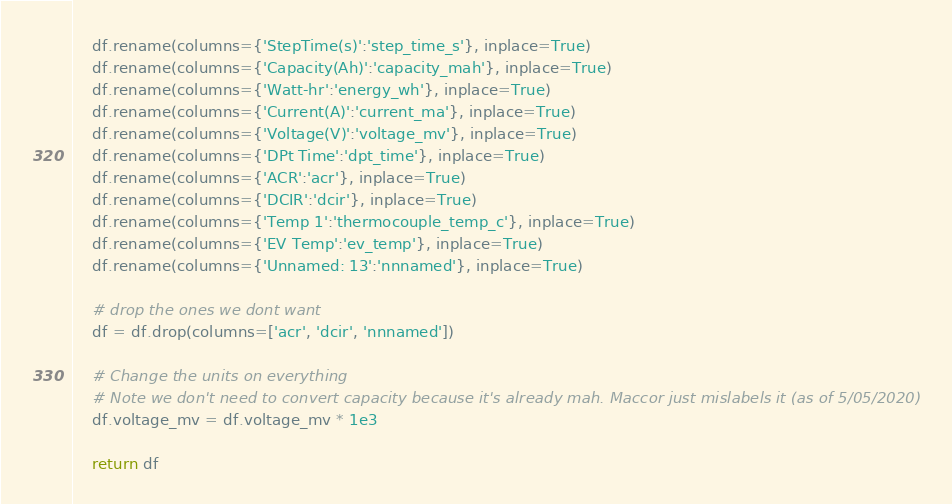<code> <loc_0><loc_0><loc_500><loc_500><_Python_>	df.rename(columns={'StepTime(s)':'step_time_s'}, inplace=True)
	df.rename(columns={'Capacity(Ah)':'capacity_mah'}, inplace=True)
	df.rename(columns={'Watt-hr':'energy_wh'}, inplace=True)
	df.rename(columns={'Current(A)':'current_ma'}, inplace=True)
	df.rename(columns={'Voltage(V)':'voltage_mv'}, inplace=True)
	df.rename(columns={'DPt Time':'dpt_time'}, inplace=True)
	df.rename(columns={'ACR':'acr'}, inplace=True)
	df.rename(columns={'DCIR':'dcir'}, inplace=True)
	df.rename(columns={'Temp 1':'thermocouple_temp_c'}, inplace=True)
	df.rename(columns={'EV Temp':'ev_temp'}, inplace=True)
	df.rename(columns={'Unnamed: 13':'nnnamed'}, inplace=True)
    
	# drop the ones we dont want
	df = df.drop(columns=['acr', 'dcir', 'nnnamed']) 
    
	# Change the units on everything
	# Note we don't need to convert capacity because it's already mah. Maccor just mislabels it (as of 5/05/2020)
	df.voltage_mv = df.voltage_mv * 1e3
    
	return df</code> 